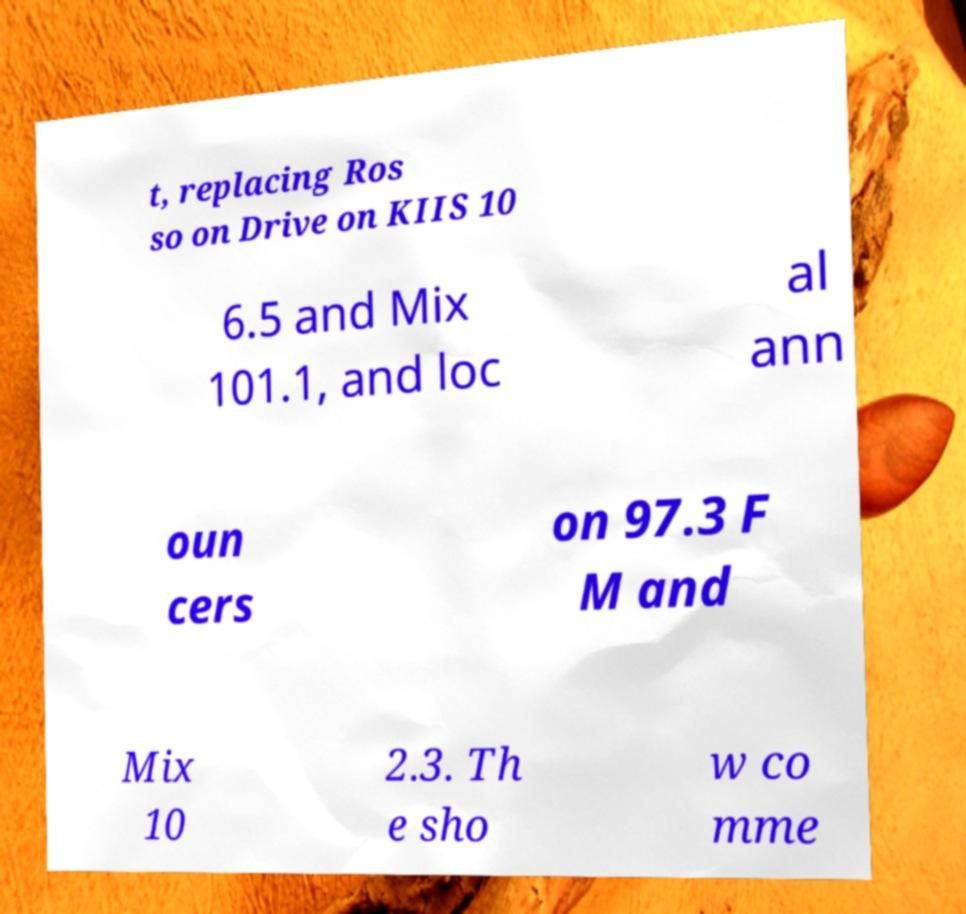There's text embedded in this image that I need extracted. Can you transcribe it verbatim? t, replacing Ros so on Drive on KIIS 10 6.5 and Mix 101.1, and loc al ann oun cers on 97.3 F M and Mix 10 2.3. Th e sho w co mme 